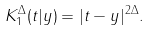Convert formula to latex. <formula><loc_0><loc_0><loc_500><loc_500>K _ { 1 } ^ { \Delta } ( t | y ) = | t - y | ^ { 2 \Delta } .</formula> 